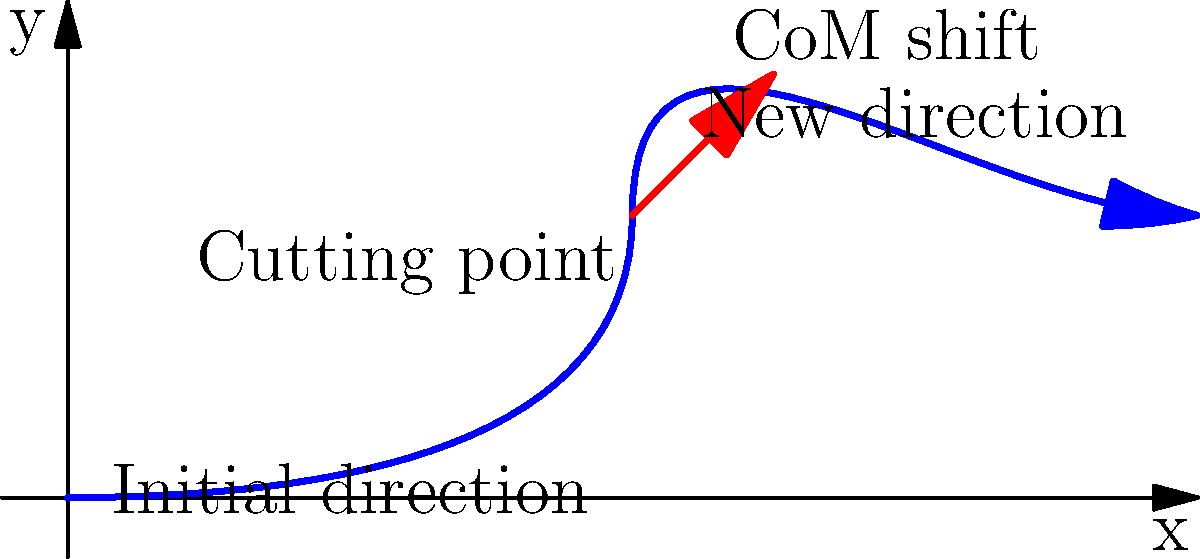In a crucial play during the 1980 Mississippi Valley State University football season, a running back performs a cutting maneuver to evade a defender. The diagram shows the path of the running back and the shift in the center of mass (CoM) during the cut. If the running back's initial velocity is $v_0 = 8$ m/s and the cut occurs over a time interval of $\Delta t = 0.5$ seconds, what is the approximate magnitude of the lateral acceleration $a_\text{lat}$ experienced by the running back during the cut? To solve this problem, we'll follow these steps:

1) First, we need to understand that the lateral acceleration is caused by the change in velocity perpendicular to the original direction of motion.

2) From the diagram, we can estimate that the lateral displacement of the center of mass is approximately half the forward displacement during the cut. Let's assume the forward displacement is about 4 meters (half of 8 m/s * 0.5 s).

3) So, the lateral displacement $\Delta y$ is approximately 2 meters.

4) We can use the equation for displacement under constant acceleration:

   $\Delta y = \frac{1}{2}a_\text{lat}(\Delta t)^2$

5) Rearranging this equation to solve for $a_\text{lat}$:

   $a_\text{lat} = \frac{2\Delta y}{(\Delta t)^2}$

6) Substituting our values:

   $a_\text{lat} = \frac{2(2 \text{ m})}{(0.5 \text{ s})^2} = \frac{4 \text{ m}}{0.25 \text{ s}^2} = 16 \text{ m/s}^2$

7) Therefore, the approximate magnitude of the lateral acceleration during the cut is 16 m/s².
Answer: 16 m/s² 